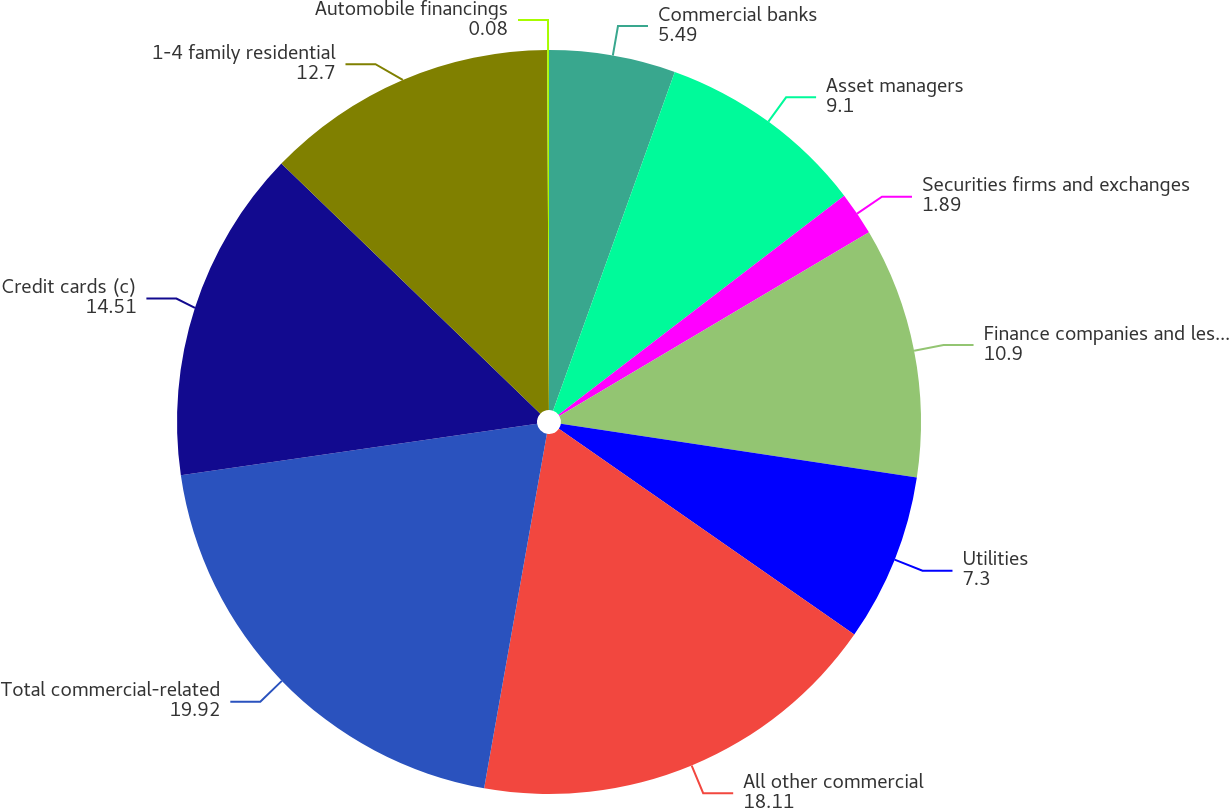Convert chart to OTSL. <chart><loc_0><loc_0><loc_500><loc_500><pie_chart><fcel>Commercial banks<fcel>Asset managers<fcel>Securities firms and exchanges<fcel>Finance companies and lessors<fcel>Utilities<fcel>All other commercial<fcel>Total commercial-related<fcel>Credit cards (c)<fcel>1-4 family residential<fcel>Automobile financings<nl><fcel>5.49%<fcel>9.1%<fcel>1.89%<fcel>10.9%<fcel>7.3%<fcel>18.11%<fcel>19.92%<fcel>14.51%<fcel>12.7%<fcel>0.08%<nl></chart> 